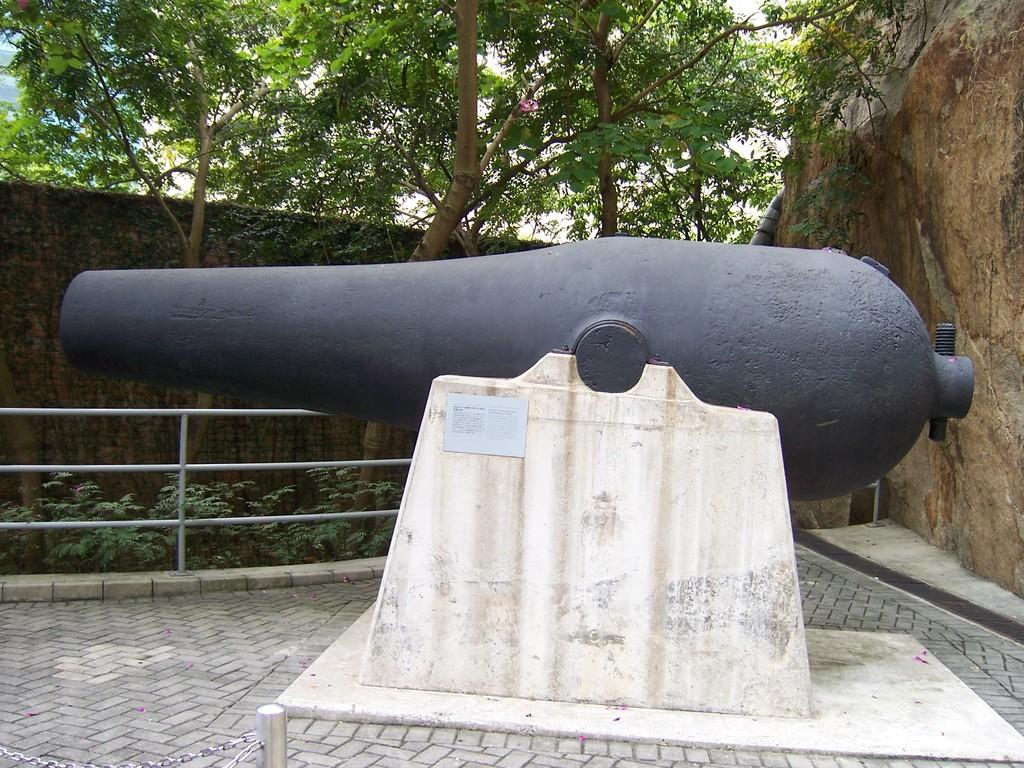What is the main object in the image? There is a cannon in the image. What type of barrier can be seen in the image? There is a fence in the image. What type of vegetation is present in the image? There are trees in the image. What type of structure can be seen in the image? There is a wall in the image. What type of natural formation is present in the image? There is a rock in the image. How many balls are visible in the image? There are no balls present in the image. Can you see any lizards in the image? There are no lizards present in the image. 